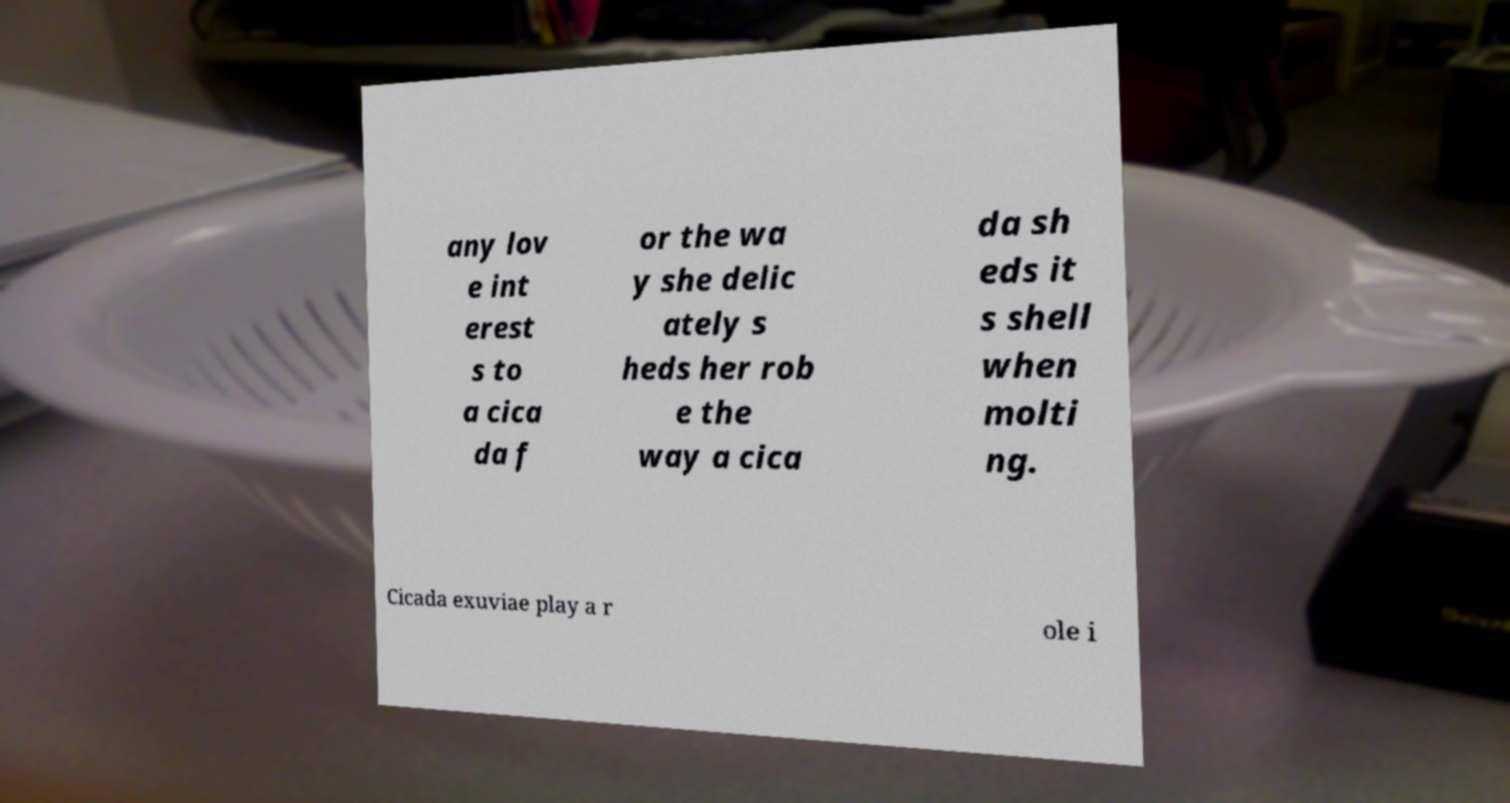For documentation purposes, I need the text within this image transcribed. Could you provide that? any lov e int erest s to a cica da f or the wa y she delic ately s heds her rob e the way a cica da sh eds it s shell when molti ng. Cicada exuviae play a r ole i 